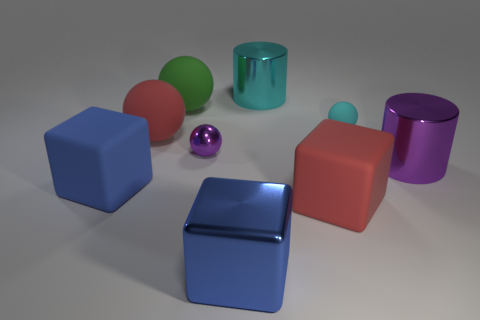Subtract all brown spheres. How many blue cubes are left? 2 Add 1 purple shiny things. How many objects exist? 10 Subtract all blue cubes. How many cubes are left? 1 Subtract 2 spheres. How many spheres are left? 2 Subtract all red balls. How many balls are left? 3 Subtract all spheres. How many objects are left? 5 Subtract 0 green blocks. How many objects are left? 9 Subtract all cyan blocks. Subtract all purple spheres. How many blocks are left? 3 Subtract all small rubber spheres. Subtract all big red matte objects. How many objects are left? 6 Add 9 cyan metal cylinders. How many cyan metal cylinders are left? 10 